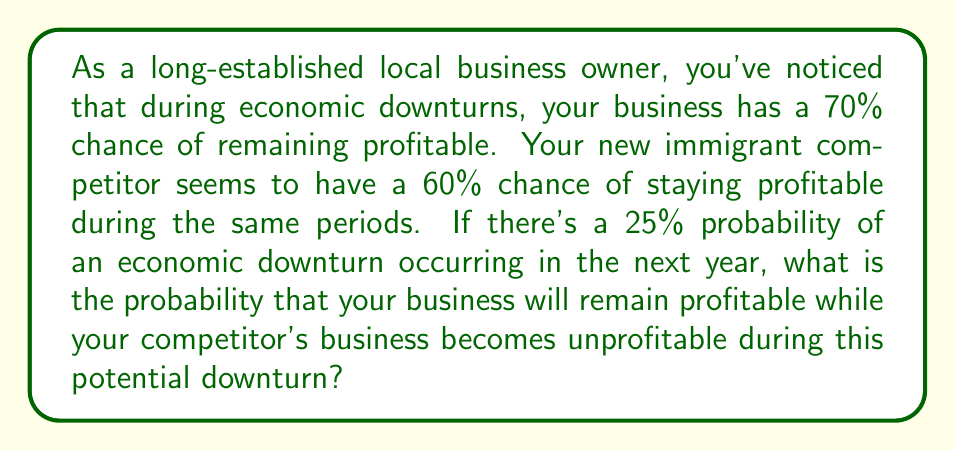Could you help me with this problem? Let's approach this step-by-step:

1) First, we need to identify the probabilities given:
   - Probability of an economic downturn: $P(D) = 0.25$
   - Probability of your business remaining profitable during a downturn: $P(Y|D) = 0.70$
   - Probability of competitor's business remaining profitable during a downturn: $P(C|D) = 0.60$

2) We're looking for the probability that your business remains profitable AND your competitor's business becomes unprofitable during a downturn. Let's call this event A.

3) We can express this as:
   $P(A) = P(D) \times P(Y|D) \times (1 - P(C|D))$

4) Here's why:
   - $P(D)$ is the probability of a downturn occurring
   - $P(Y|D)$ is the probability of your business remaining profitable given a downturn
   - $(1 - P(C|D))$ is the probability of your competitor's business becoming unprofitable given a downturn

5) Now, let's substitute the values:
   $P(A) = 0.25 \times 0.70 \times (1 - 0.60)$

6) Simplify:
   $P(A) = 0.25 \times 0.70 \times 0.40$

7) Calculate:
   $P(A) = 0.07$ or 7%
Answer: The probability that your business will remain profitable while your competitor's business becomes unprofitable during a potential economic downturn in the next year is 0.07 or 7%. 